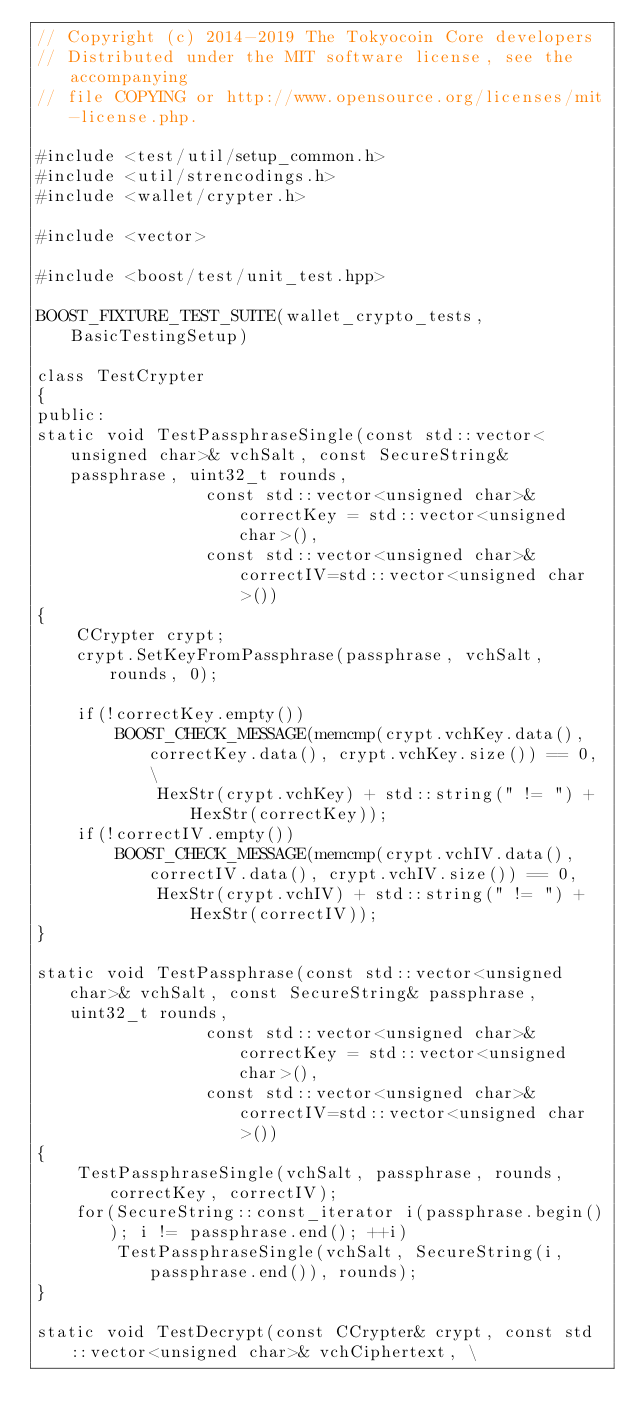Convert code to text. <code><loc_0><loc_0><loc_500><loc_500><_C++_>// Copyright (c) 2014-2019 The Tokyocoin Core developers
// Distributed under the MIT software license, see the accompanying
// file COPYING or http://www.opensource.org/licenses/mit-license.php.

#include <test/util/setup_common.h>
#include <util/strencodings.h>
#include <wallet/crypter.h>

#include <vector>

#include <boost/test/unit_test.hpp>

BOOST_FIXTURE_TEST_SUITE(wallet_crypto_tests, BasicTestingSetup)

class TestCrypter
{
public:
static void TestPassphraseSingle(const std::vector<unsigned char>& vchSalt, const SecureString& passphrase, uint32_t rounds,
                 const std::vector<unsigned char>& correctKey = std::vector<unsigned char>(),
                 const std::vector<unsigned char>& correctIV=std::vector<unsigned char>())
{
    CCrypter crypt;
    crypt.SetKeyFromPassphrase(passphrase, vchSalt, rounds, 0);

    if(!correctKey.empty())
        BOOST_CHECK_MESSAGE(memcmp(crypt.vchKey.data(), correctKey.data(), crypt.vchKey.size()) == 0, \
            HexStr(crypt.vchKey) + std::string(" != ") + HexStr(correctKey));
    if(!correctIV.empty())
        BOOST_CHECK_MESSAGE(memcmp(crypt.vchIV.data(), correctIV.data(), crypt.vchIV.size()) == 0,
            HexStr(crypt.vchIV) + std::string(" != ") + HexStr(correctIV));
}

static void TestPassphrase(const std::vector<unsigned char>& vchSalt, const SecureString& passphrase, uint32_t rounds,
                 const std::vector<unsigned char>& correctKey = std::vector<unsigned char>(),
                 const std::vector<unsigned char>& correctIV=std::vector<unsigned char>())
{
    TestPassphraseSingle(vchSalt, passphrase, rounds, correctKey, correctIV);
    for(SecureString::const_iterator i(passphrase.begin()); i != passphrase.end(); ++i)
        TestPassphraseSingle(vchSalt, SecureString(i, passphrase.end()), rounds);
}

static void TestDecrypt(const CCrypter& crypt, const std::vector<unsigned char>& vchCiphertext, \</code> 